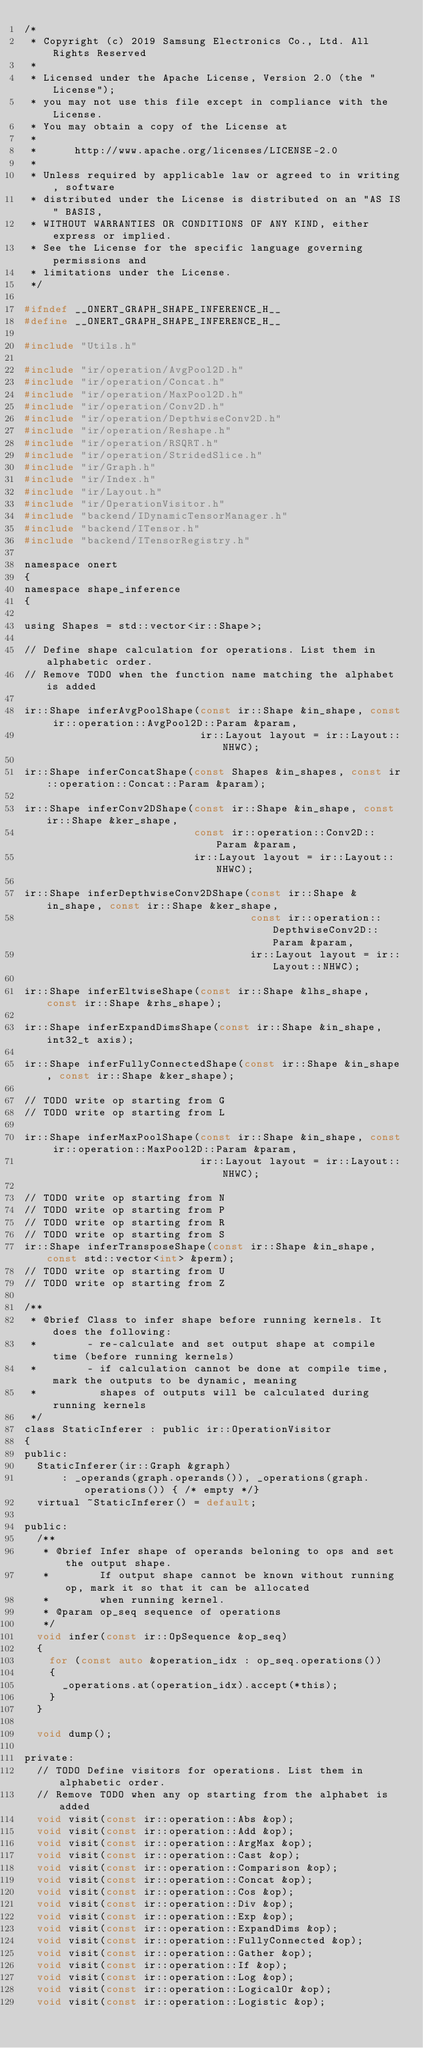Convert code to text. <code><loc_0><loc_0><loc_500><loc_500><_C_>/*
 * Copyright (c) 2019 Samsung Electronics Co., Ltd. All Rights Reserved
 *
 * Licensed under the Apache License, Version 2.0 (the "License");
 * you may not use this file except in compliance with the License.
 * You may obtain a copy of the License at
 *
 *      http://www.apache.org/licenses/LICENSE-2.0
 *
 * Unless required by applicable law or agreed to in writing, software
 * distributed under the License is distributed on an "AS IS" BASIS,
 * WITHOUT WARRANTIES OR CONDITIONS OF ANY KIND, either express or implied.
 * See the License for the specific language governing permissions and
 * limitations under the License.
 */

#ifndef __ONERT_GRAPH_SHAPE_INFERENCE_H__
#define __ONERT_GRAPH_SHAPE_INFERENCE_H__

#include "Utils.h"

#include "ir/operation/AvgPool2D.h"
#include "ir/operation/Concat.h"
#include "ir/operation/MaxPool2D.h"
#include "ir/operation/Conv2D.h"
#include "ir/operation/DepthwiseConv2D.h"
#include "ir/operation/Reshape.h"
#include "ir/operation/RSQRT.h"
#include "ir/operation/StridedSlice.h"
#include "ir/Graph.h"
#include "ir/Index.h"
#include "ir/Layout.h"
#include "ir/OperationVisitor.h"
#include "backend/IDynamicTensorManager.h"
#include "backend/ITensor.h"
#include "backend/ITensorRegistry.h"

namespace onert
{
namespace shape_inference
{

using Shapes = std::vector<ir::Shape>;

// Define shape calculation for operations. List them in alphabetic order.
// Remove TODO when the function name matching the alphabet is added

ir::Shape inferAvgPoolShape(const ir::Shape &in_shape, const ir::operation::AvgPool2D::Param &param,
                            ir::Layout layout = ir::Layout::NHWC);

ir::Shape inferConcatShape(const Shapes &in_shapes, const ir::operation::Concat::Param &param);

ir::Shape inferConv2DShape(const ir::Shape &in_shape, const ir::Shape &ker_shape,
                           const ir::operation::Conv2D::Param &param,
                           ir::Layout layout = ir::Layout::NHWC);

ir::Shape inferDepthwiseConv2DShape(const ir::Shape &in_shape, const ir::Shape &ker_shape,
                                    const ir::operation::DepthwiseConv2D::Param &param,
                                    ir::Layout layout = ir::Layout::NHWC);

ir::Shape inferEltwiseShape(const ir::Shape &lhs_shape, const ir::Shape &rhs_shape);

ir::Shape inferExpandDimsShape(const ir::Shape &in_shape, int32_t axis);

ir::Shape inferFullyConnectedShape(const ir::Shape &in_shape, const ir::Shape &ker_shape);

// TODO write op starting from G
// TODO write op starting from L

ir::Shape inferMaxPoolShape(const ir::Shape &in_shape, const ir::operation::MaxPool2D::Param &param,
                            ir::Layout layout = ir::Layout::NHWC);

// TODO write op starting from N
// TODO write op starting from P
// TODO write op starting from R
// TODO write op starting from S
ir::Shape inferTransposeShape(const ir::Shape &in_shape, const std::vector<int> &perm);
// TODO write op starting from U
// TODO write op starting from Z

/**
 * @brief Class to infer shape before running kernels. It does the following:
 *        - re-calculate and set output shape at compile time (before running kernels)
 *        - if calculation cannot be done at compile time, mark the outputs to be dynamic, meaning
 *          shapes of outputs will be calculated during running kernels
 */
class StaticInferer : public ir::OperationVisitor
{
public:
  StaticInferer(ir::Graph &graph)
      : _operands(graph.operands()), _operations(graph.operations()) { /* empty */}
  virtual ~StaticInferer() = default;

public:
  /**
   * @brief Infer shape of operands beloning to ops and set the output shape.
   *        If output shape cannot be known without running op, mark it so that it can be allocated
   *        when running kernel.
   * @param op_seq sequence of operations
   */
  void infer(const ir::OpSequence &op_seq)
  {
    for (const auto &operation_idx : op_seq.operations())
    {
      _operations.at(operation_idx).accept(*this);
    }
  }

  void dump();

private:
  // TODO Define visitors for operations. List them in alphabetic order.
  // Remove TODO when any op starting from the alphabet is added
  void visit(const ir::operation::Abs &op);
  void visit(const ir::operation::Add &op);
  void visit(const ir::operation::ArgMax &op);
  void visit(const ir::operation::Cast &op);
  void visit(const ir::operation::Comparison &op);
  void visit(const ir::operation::Concat &op);
  void visit(const ir::operation::Cos &op);
  void visit(const ir::operation::Div &op);
  void visit(const ir::operation::Exp &op);
  void visit(const ir::operation::ExpandDims &op);
  void visit(const ir::operation::FullyConnected &op);
  void visit(const ir::operation::Gather &op);
  void visit(const ir::operation::If &op);
  void visit(const ir::operation::Log &op);
  void visit(const ir::operation::LogicalOr &op);
  void visit(const ir::operation::Logistic &op);</code> 